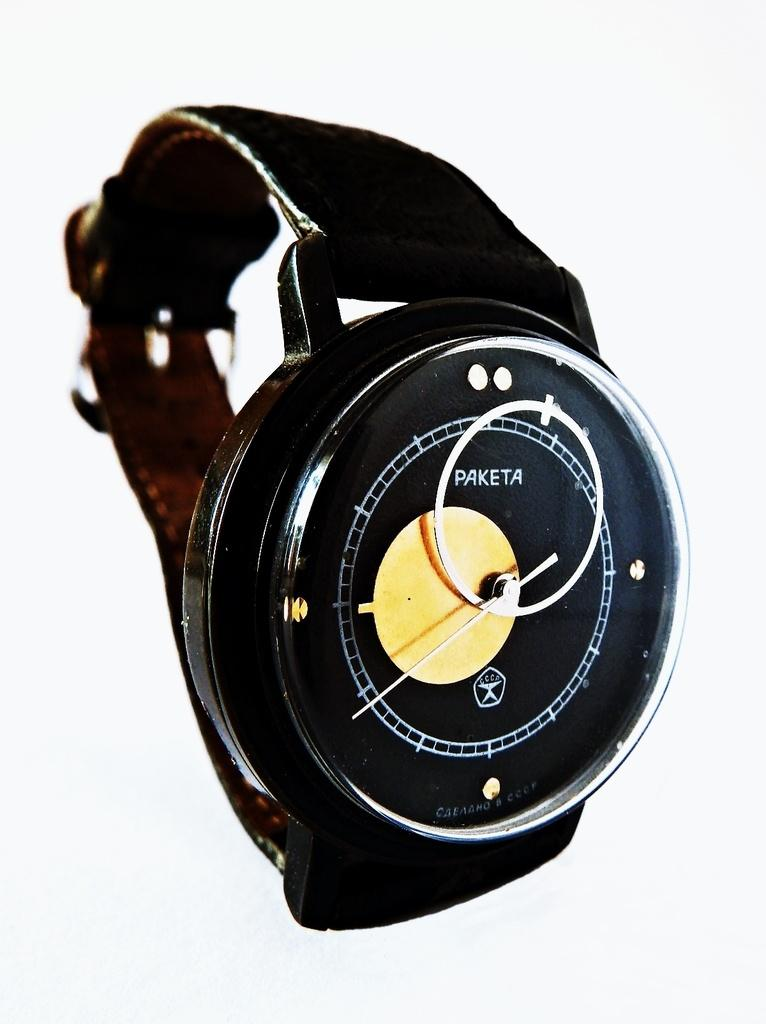<image>
Share a concise interpretation of the image provided. Black wristwatch with the work PAKETA on it. 